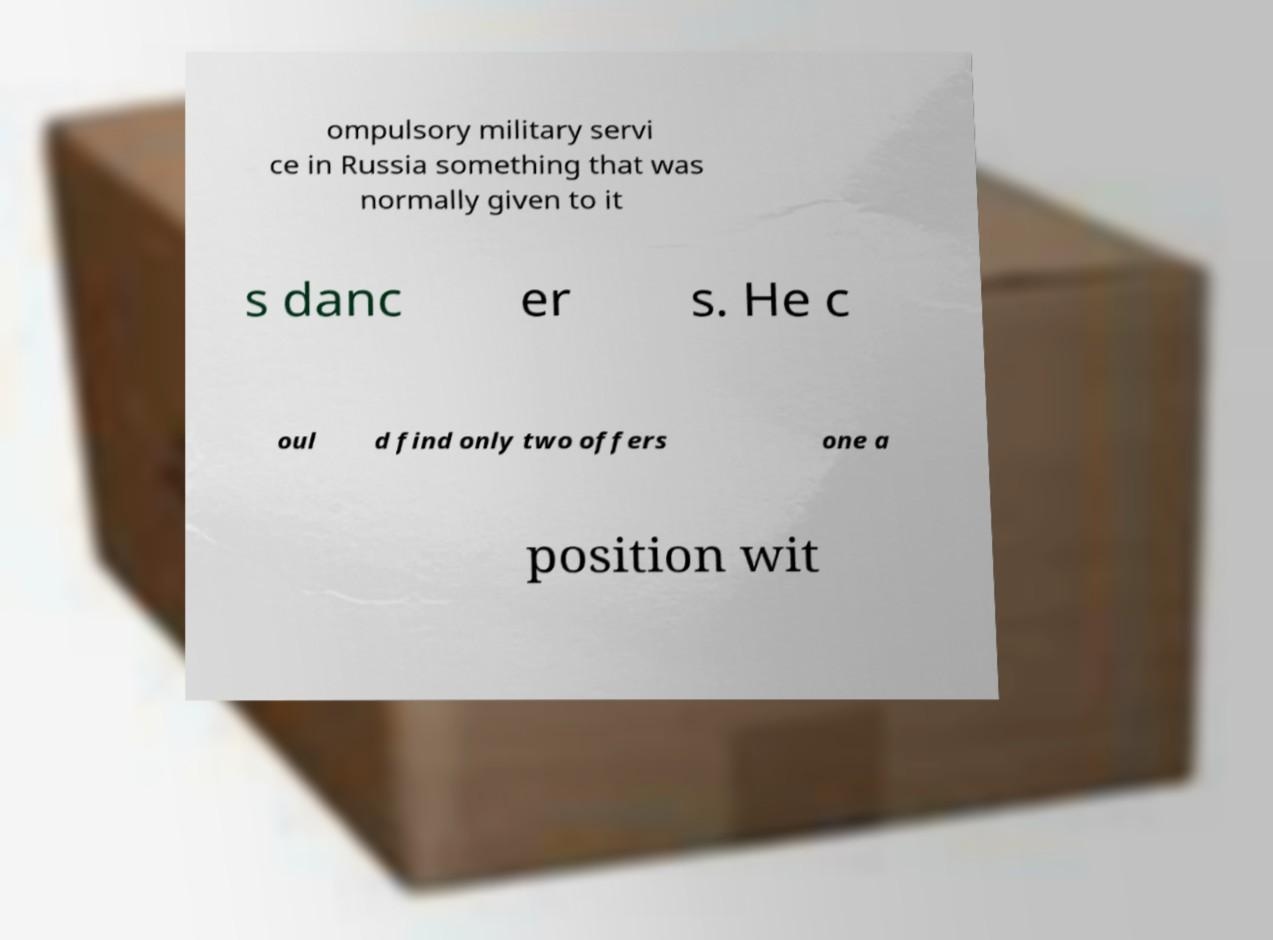Can you read and provide the text displayed in the image?This photo seems to have some interesting text. Can you extract and type it out for me? ompulsory military servi ce in Russia something that was normally given to it s danc er s. He c oul d find only two offers one a position wit 